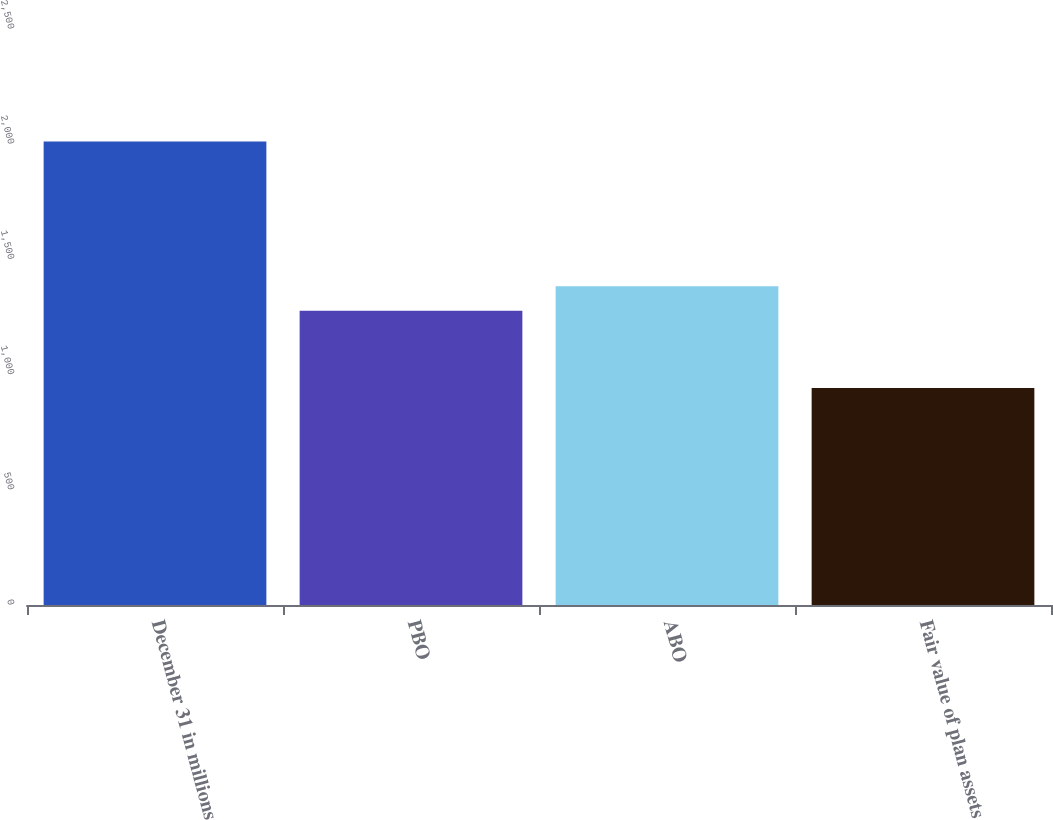Convert chart. <chart><loc_0><loc_0><loc_500><loc_500><bar_chart><fcel>December 31 in millions<fcel>PBO<fcel>ABO<fcel>Fair value of plan assets<nl><fcel>2012<fcel>1277<fcel>1384<fcel>942<nl></chart> 